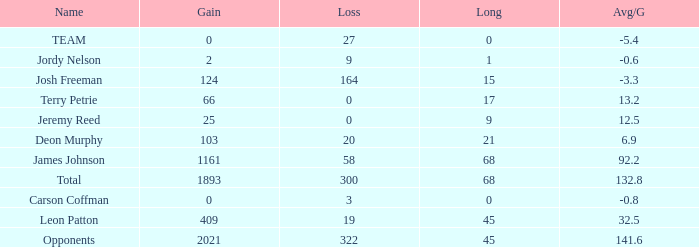Would you mind parsing the complete table? {'header': ['Name', 'Gain', 'Loss', 'Long', 'Avg/G'], 'rows': [['TEAM', '0', '27', '0', '-5.4'], ['Jordy Nelson', '2', '9', '1', '-0.6'], ['Josh Freeman', '124', '164', '15', '-3.3'], ['Terry Petrie', '66', '0', '17', '13.2'], ['Jeremy Reed', '25', '0', '9', '12.5'], ['Deon Murphy', '103', '20', '21', '6.9'], ['James Johnson', '1161', '58', '68', '92.2'], ['Total', '1893', '300', '68', '132.8'], ['Carson Coffman', '0', '3', '0', '-0.8'], ['Leon Patton', '409', '19', '45', '32.5'], ['Opponents', '2021', '322', '45', '141.6']]} How many losses did leon patton have with the longest gain higher than 45? 0.0. 